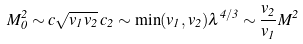<formula> <loc_0><loc_0><loc_500><loc_500>M _ { 0 } ^ { 2 } \sim c \sqrt { v _ { 1 } v _ { 2 } } \, c _ { 2 } \sim \min ( v _ { 1 } , v _ { 2 } ) \lambda ^ { 4 / 3 } \sim \frac { v _ { 2 } } { v _ { 1 } } M ^ { 2 }</formula> 